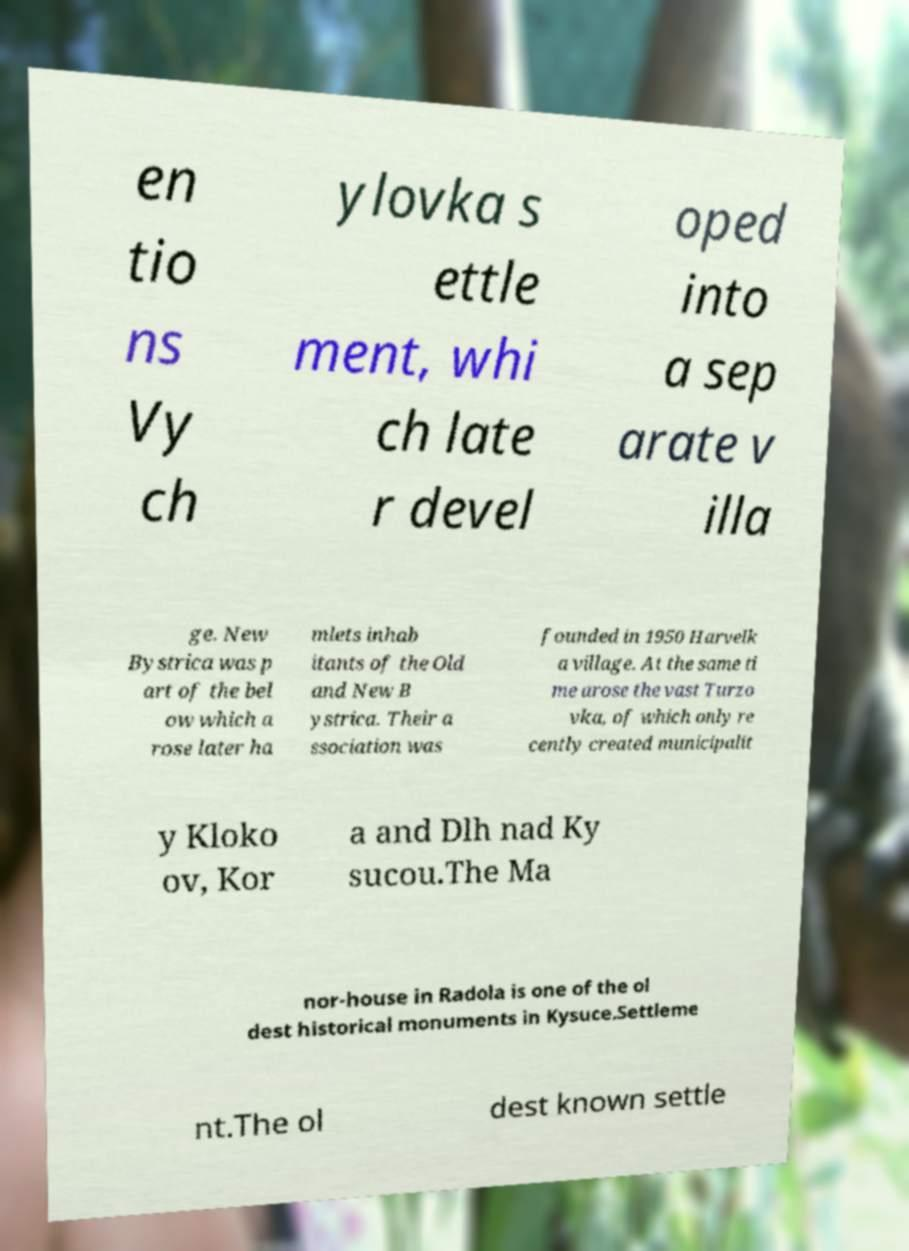There's text embedded in this image that I need extracted. Can you transcribe it verbatim? en tio ns Vy ch ylovka s ettle ment, whi ch late r devel oped into a sep arate v illa ge. New Bystrica was p art of the bel ow which a rose later ha mlets inhab itants of the Old and New B ystrica. Their a ssociation was founded in 1950 Harvelk a village. At the same ti me arose the vast Turzo vka, of which only re cently created municipalit y Kloko ov, Kor a and Dlh nad Ky sucou.The Ma nor-house in Radola is one of the ol dest historical monuments in Kysuce.Settleme nt.The ol dest known settle 